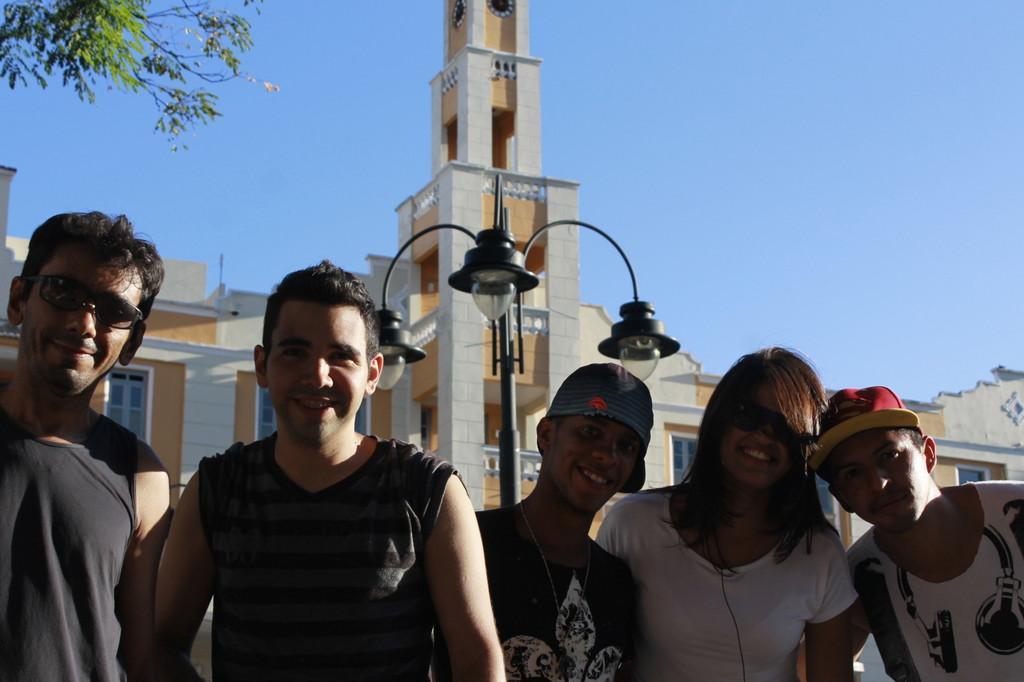Can you describe this image briefly? This picture is clicked outside. In the foreground we can see the group of people seems to be standing. In the background we can see the sky, lamppost, buildings, tree and the clocks hanging on the walls of the building and we can see some other items. 